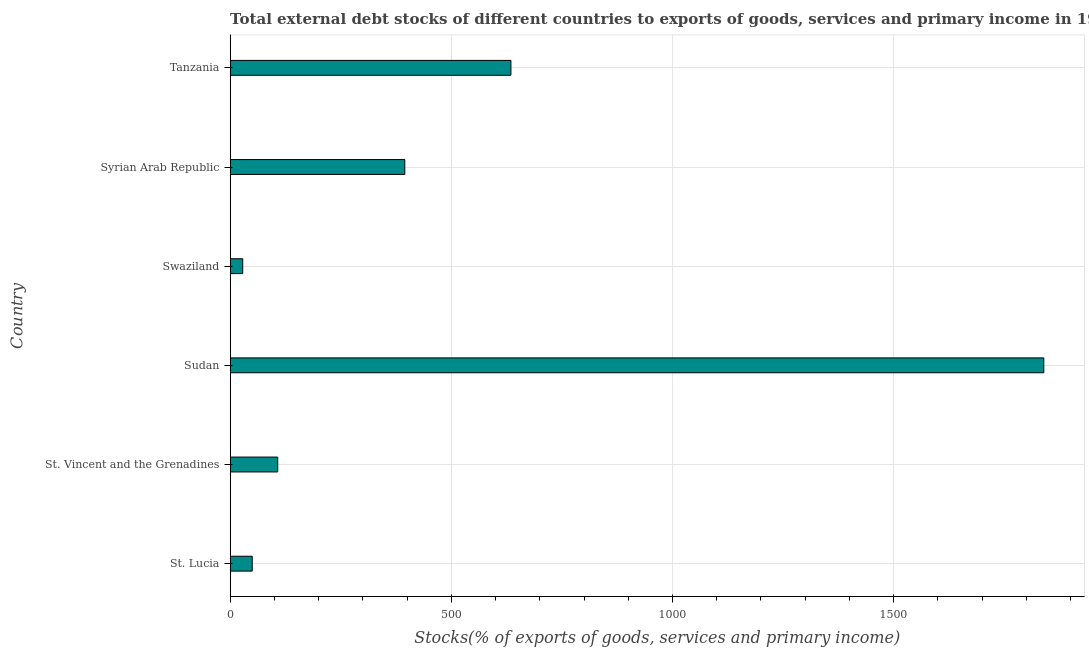What is the title of the graph?
Make the answer very short. Total external debt stocks of different countries to exports of goods, services and primary income in 1999. What is the label or title of the X-axis?
Make the answer very short. Stocks(% of exports of goods, services and primary income). What is the external debt stocks in St. Vincent and the Grenadines?
Keep it short and to the point. 107.46. Across all countries, what is the maximum external debt stocks?
Provide a short and direct response. 1839.63. Across all countries, what is the minimum external debt stocks?
Ensure brevity in your answer.  28.37. In which country was the external debt stocks maximum?
Provide a succinct answer. Sudan. In which country was the external debt stocks minimum?
Provide a short and direct response. Swaziland. What is the sum of the external debt stocks?
Offer a very short reply. 3054.83. What is the difference between the external debt stocks in Syrian Arab Republic and Tanzania?
Make the answer very short. -239.94. What is the average external debt stocks per country?
Provide a succinct answer. 509.14. What is the median external debt stocks?
Provide a short and direct response. 251.14. What is the ratio of the external debt stocks in St. Vincent and the Grenadines to that in Tanzania?
Your answer should be very brief. 0.17. Is the external debt stocks in St. Vincent and the Grenadines less than that in Sudan?
Make the answer very short. Yes. What is the difference between the highest and the second highest external debt stocks?
Ensure brevity in your answer.  1204.88. Is the sum of the external debt stocks in St. Vincent and the Grenadines and Sudan greater than the maximum external debt stocks across all countries?
Your answer should be very brief. Yes. What is the difference between the highest and the lowest external debt stocks?
Ensure brevity in your answer.  1811.26. How many bars are there?
Make the answer very short. 6. Are all the bars in the graph horizontal?
Your answer should be compact. Yes. How many countries are there in the graph?
Keep it short and to the point. 6. Are the values on the major ticks of X-axis written in scientific E-notation?
Provide a short and direct response. No. What is the Stocks(% of exports of goods, services and primary income) in St. Lucia?
Provide a succinct answer. 49.81. What is the Stocks(% of exports of goods, services and primary income) of St. Vincent and the Grenadines?
Provide a succinct answer. 107.46. What is the Stocks(% of exports of goods, services and primary income) in Sudan?
Your answer should be very brief. 1839.63. What is the Stocks(% of exports of goods, services and primary income) in Swaziland?
Your answer should be very brief. 28.37. What is the Stocks(% of exports of goods, services and primary income) in Syrian Arab Republic?
Provide a short and direct response. 394.81. What is the Stocks(% of exports of goods, services and primary income) in Tanzania?
Keep it short and to the point. 634.75. What is the difference between the Stocks(% of exports of goods, services and primary income) in St. Lucia and St. Vincent and the Grenadines?
Ensure brevity in your answer.  -57.65. What is the difference between the Stocks(% of exports of goods, services and primary income) in St. Lucia and Sudan?
Your answer should be compact. -1789.82. What is the difference between the Stocks(% of exports of goods, services and primary income) in St. Lucia and Swaziland?
Give a very brief answer. 21.44. What is the difference between the Stocks(% of exports of goods, services and primary income) in St. Lucia and Syrian Arab Republic?
Your answer should be compact. -345. What is the difference between the Stocks(% of exports of goods, services and primary income) in St. Lucia and Tanzania?
Provide a short and direct response. -584.93. What is the difference between the Stocks(% of exports of goods, services and primary income) in St. Vincent and the Grenadines and Sudan?
Your answer should be very brief. -1732.17. What is the difference between the Stocks(% of exports of goods, services and primary income) in St. Vincent and the Grenadines and Swaziland?
Provide a succinct answer. 79.09. What is the difference between the Stocks(% of exports of goods, services and primary income) in St. Vincent and the Grenadines and Syrian Arab Republic?
Make the answer very short. -287.35. What is the difference between the Stocks(% of exports of goods, services and primary income) in St. Vincent and the Grenadines and Tanzania?
Make the answer very short. -527.28. What is the difference between the Stocks(% of exports of goods, services and primary income) in Sudan and Swaziland?
Provide a succinct answer. 1811.26. What is the difference between the Stocks(% of exports of goods, services and primary income) in Sudan and Syrian Arab Republic?
Provide a succinct answer. 1444.82. What is the difference between the Stocks(% of exports of goods, services and primary income) in Sudan and Tanzania?
Offer a terse response. 1204.89. What is the difference between the Stocks(% of exports of goods, services and primary income) in Swaziland and Syrian Arab Republic?
Keep it short and to the point. -366.44. What is the difference between the Stocks(% of exports of goods, services and primary income) in Swaziland and Tanzania?
Provide a short and direct response. -606.37. What is the difference between the Stocks(% of exports of goods, services and primary income) in Syrian Arab Republic and Tanzania?
Give a very brief answer. -239.94. What is the ratio of the Stocks(% of exports of goods, services and primary income) in St. Lucia to that in St. Vincent and the Grenadines?
Offer a terse response. 0.46. What is the ratio of the Stocks(% of exports of goods, services and primary income) in St. Lucia to that in Sudan?
Keep it short and to the point. 0.03. What is the ratio of the Stocks(% of exports of goods, services and primary income) in St. Lucia to that in Swaziland?
Provide a succinct answer. 1.76. What is the ratio of the Stocks(% of exports of goods, services and primary income) in St. Lucia to that in Syrian Arab Republic?
Your answer should be compact. 0.13. What is the ratio of the Stocks(% of exports of goods, services and primary income) in St. Lucia to that in Tanzania?
Provide a short and direct response. 0.08. What is the ratio of the Stocks(% of exports of goods, services and primary income) in St. Vincent and the Grenadines to that in Sudan?
Your answer should be compact. 0.06. What is the ratio of the Stocks(% of exports of goods, services and primary income) in St. Vincent and the Grenadines to that in Swaziland?
Your response must be concise. 3.79. What is the ratio of the Stocks(% of exports of goods, services and primary income) in St. Vincent and the Grenadines to that in Syrian Arab Republic?
Ensure brevity in your answer.  0.27. What is the ratio of the Stocks(% of exports of goods, services and primary income) in St. Vincent and the Grenadines to that in Tanzania?
Make the answer very short. 0.17. What is the ratio of the Stocks(% of exports of goods, services and primary income) in Sudan to that in Swaziland?
Make the answer very short. 64.84. What is the ratio of the Stocks(% of exports of goods, services and primary income) in Sudan to that in Syrian Arab Republic?
Offer a terse response. 4.66. What is the ratio of the Stocks(% of exports of goods, services and primary income) in Sudan to that in Tanzania?
Offer a terse response. 2.9. What is the ratio of the Stocks(% of exports of goods, services and primary income) in Swaziland to that in Syrian Arab Republic?
Provide a short and direct response. 0.07. What is the ratio of the Stocks(% of exports of goods, services and primary income) in Swaziland to that in Tanzania?
Make the answer very short. 0.04. What is the ratio of the Stocks(% of exports of goods, services and primary income) in Syrian Arab Republic to that in Tanzania?
Provide a short and direct response. 0.62. 